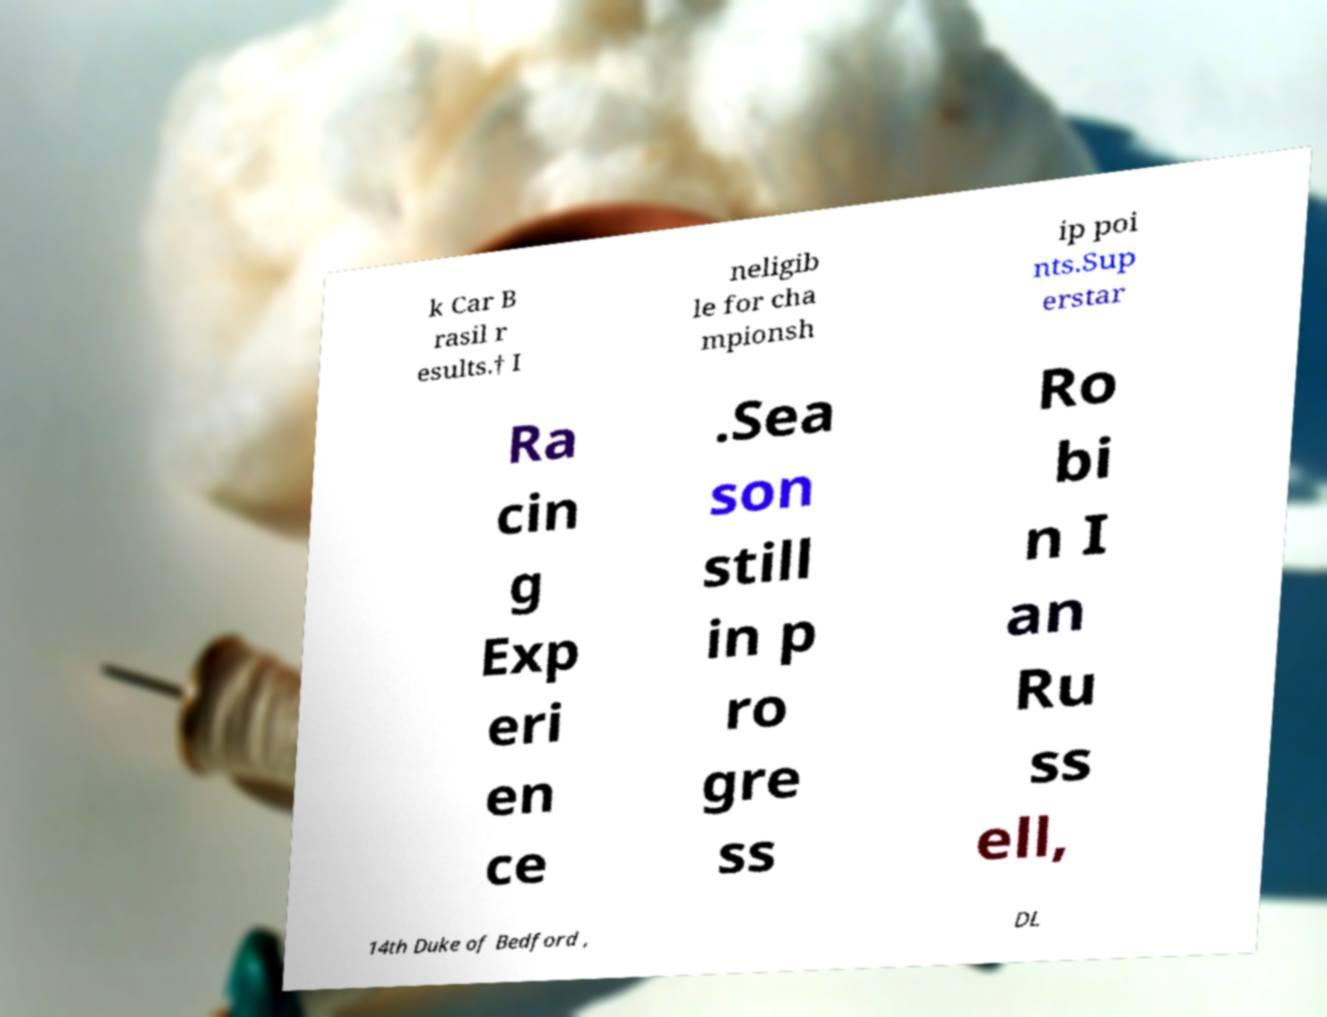Please read and relay the text visible in this image. What does it say? k Car B rasil r esults.† I neligib le for cha mpionsh ip poi nts.Sup erstar Ra cin g Exp eri en ce .Sea son still in p ro gre ss Ro bi n I an Ru ss ell, 14th Duke of Bedford , DL 